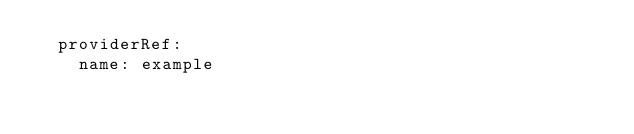<code> <loc_0><loc_0><loc_500><loc_500><_YAML_>  providerRef:
    name: example
</code> 